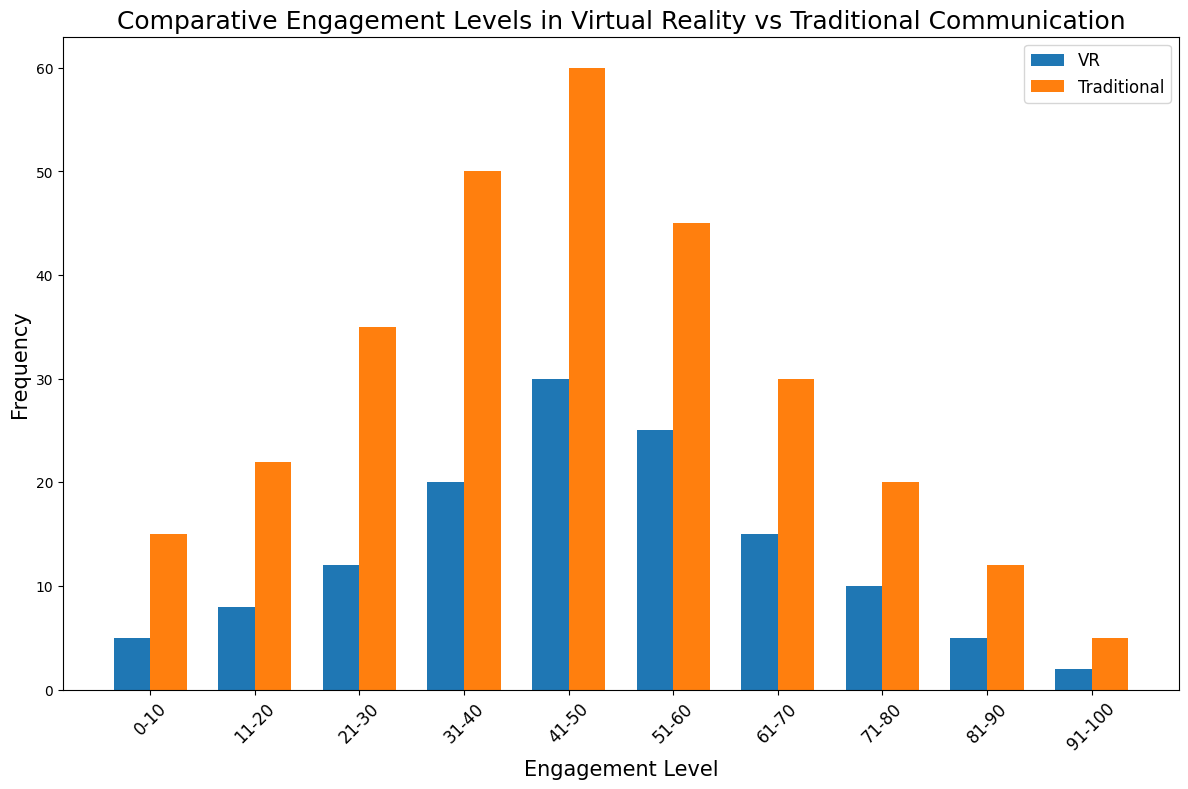Which engagement level has the highest frequency for VR? By observing the height of the bars for the VR category, the bar corresponding to the 41-50 engagement level is the tallest, indicating the highest frequency.
Answer: 41-50 Which communication method has higher frequencies overall, VR or Traditional? By visually comparing the heights of the pairs of bars for each engagement level, it can be seen that the Traditional communication bars are generally taller than the VR bars, indicating higher overall frequencies.
Answer: Traditional What is the frequency difference between VR and Traditional communication at the 51-60 engagement level? The bar heights at the 51-60 engagement level show that VR has a frequency of 25, while Traditional has a frequency of 45. The difference is calculated as 45 - 25.
Answer: 20 What engagement level range shows the smallest frequency for VR, and what is the frequency? By identifying the shortest bar for the VR category, the 91-100 engagement level range can be seen with the shortest bar at a frequency of 2.
Answer: 91-100, 2 Which engagement level shows the largest difference in frequency between VR and Traditional communication, and what is that difference? To find the largest frequency difference, we compare the heights of each pair of bars and calculate the differences: 10, 14, 23, 30, 30, 20, 15, 10, 7, 3. The largest difference is at the engagement level 31-40 or 41-50 with a frequency difference of 30.
Answer: 31-40 or 41-50, 30 At what engagement levels does VR outnumber Traditional communication in frequency? By comparing the heights, it can be seen that VR does not outnumber Traditional communication in frequency at any engagement level.
Answer: None What is the total combined frequency of the VR category across all engagement levels? Sum up all the frequencies in the VR category: 5 + 8 + 12 + 20 + 30 + 25 + 15 + 10 + 5 + 2 = 132.
Answer: 132 What is the average frequency for Traditional communication across all engagement levels? Sum up all the frequencies in the Traditional communication category and divide by the number of engagement levels: (15 + 22 + 35 + 50 + 60 + 45 + 30 + 20 + 12 + 5) / 10 = 29.4.
Answer: 29.4 How does the frequency distribution change between low (0-50) and high (51-100) engagement levels in VR communication? Sum the frequencies for low and high engagement levels in VR: For 0-50: 5 + 8 + 12 + 20 + 30 = 75. For 51-100: 25 + 15 + 10 + 5 + 2 = 57. Compare sum totals: 75 (low) vs 57 (high).
Answer: Higher in low, lower in high 